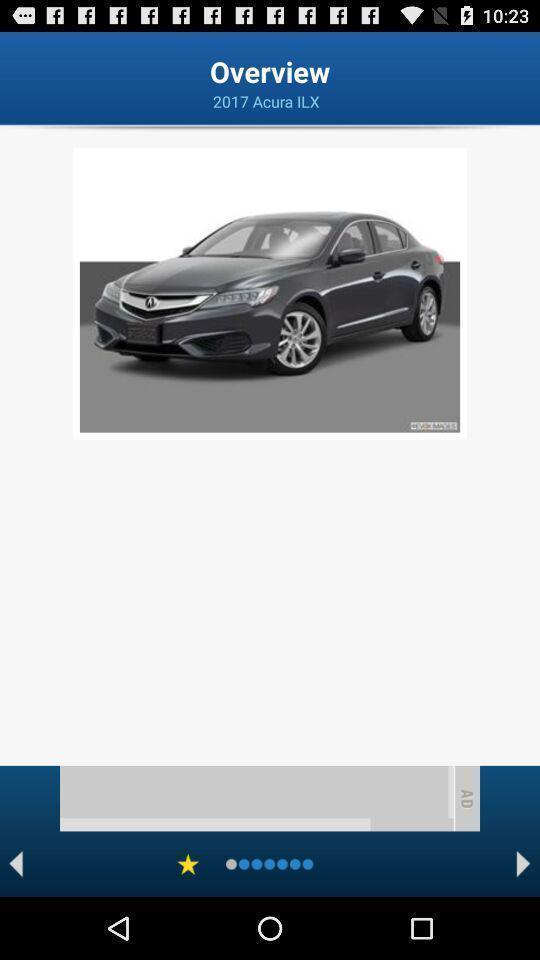Give me a narrative description of this picture. Page displaying overview of a vehicle. 